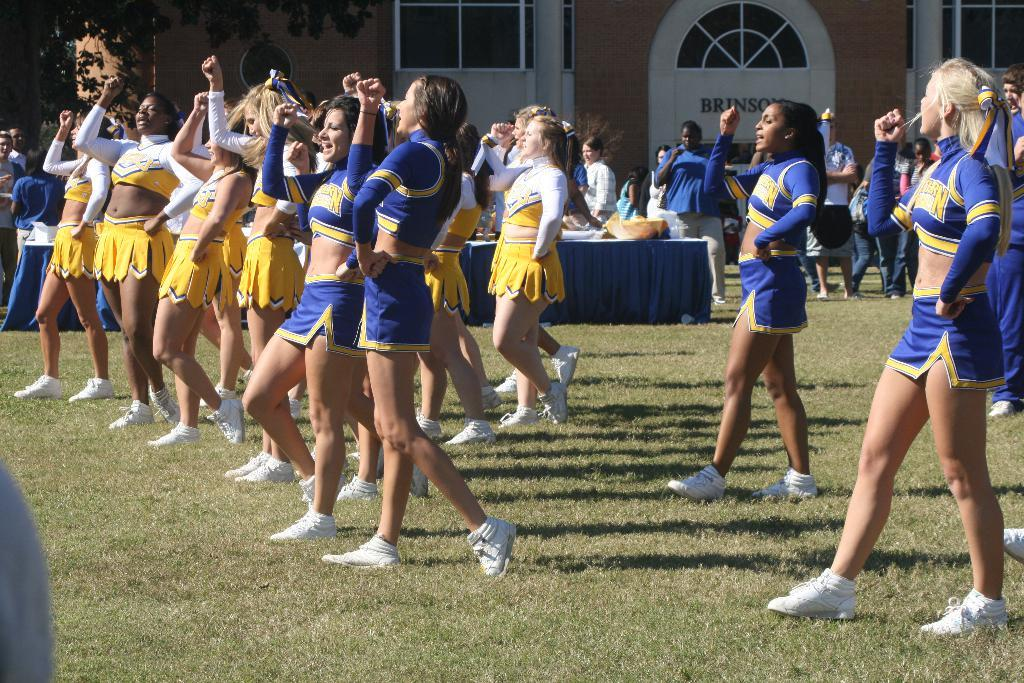<image>
Provide a brief description of the given image. cheerleaders in blue and others in yellow in front of building with brinson on it 